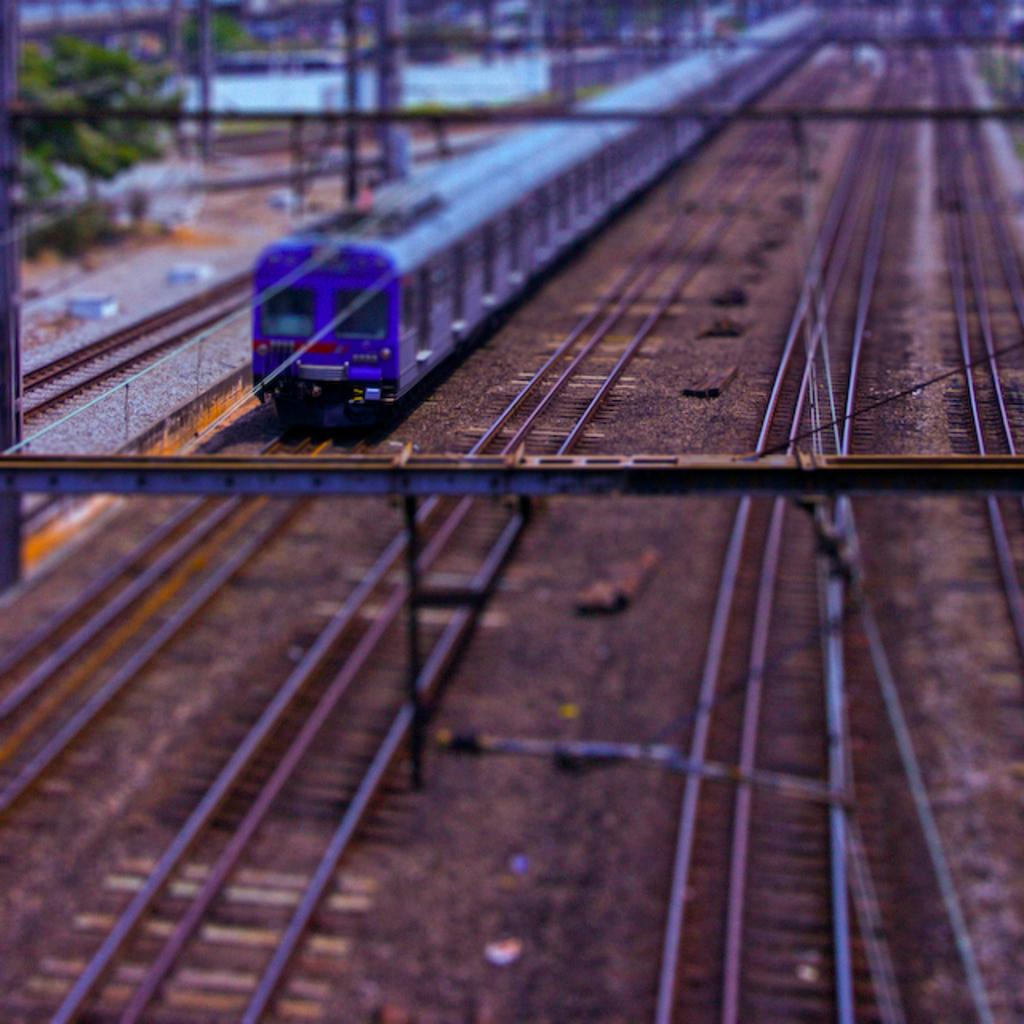What is the main subject of the image? There is a train in the image. Where is the train located? The train is on a railway track. How many railway tracks are visible in the image? There are multiple railway tracks in the image. What can be seen in the background of the image? There are trees and some unspecified objects in the background of the image. How would you describe the quality of the image? The image is blurry. What title is written on the train in the image? There is no title visible on the train in the image. How is the paste being used in the image? There is no paste present in the image. 